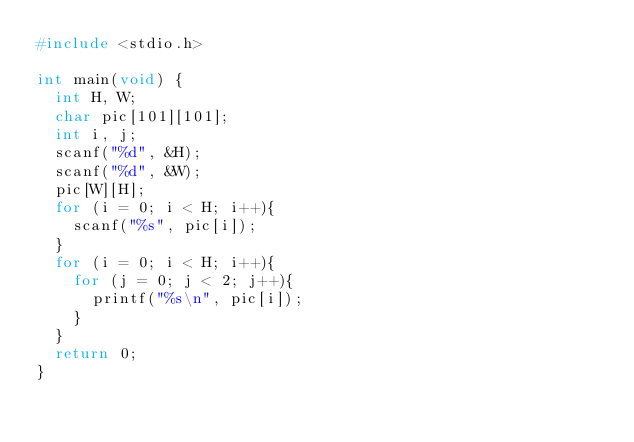<code> <loc_0><loc_0><loc_500><loc_500><_C_>#include <stdio.h>

int main(void) {
	int H, W;
	char pic[101][101];
	int i, j;
	scanf("%d", &H);
	scanf("%d", &W);
	pic[W][H];
	for (i = 0; i < H; i++){
		scanf("%s", pic[i]);
	}
	for (i = 0; i < H; i++){
		for (j = 0; j < 2; j++){
			printf("%s\n", pic[i]);
		}
	}
	return 0;
}</code> 